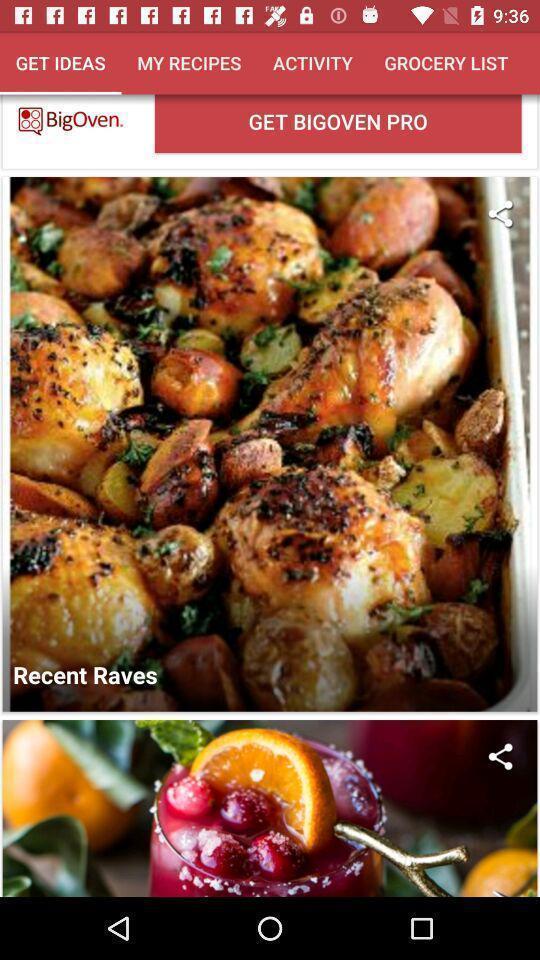Summarize the information in this screenshot. Screen displaying list of recipes. 